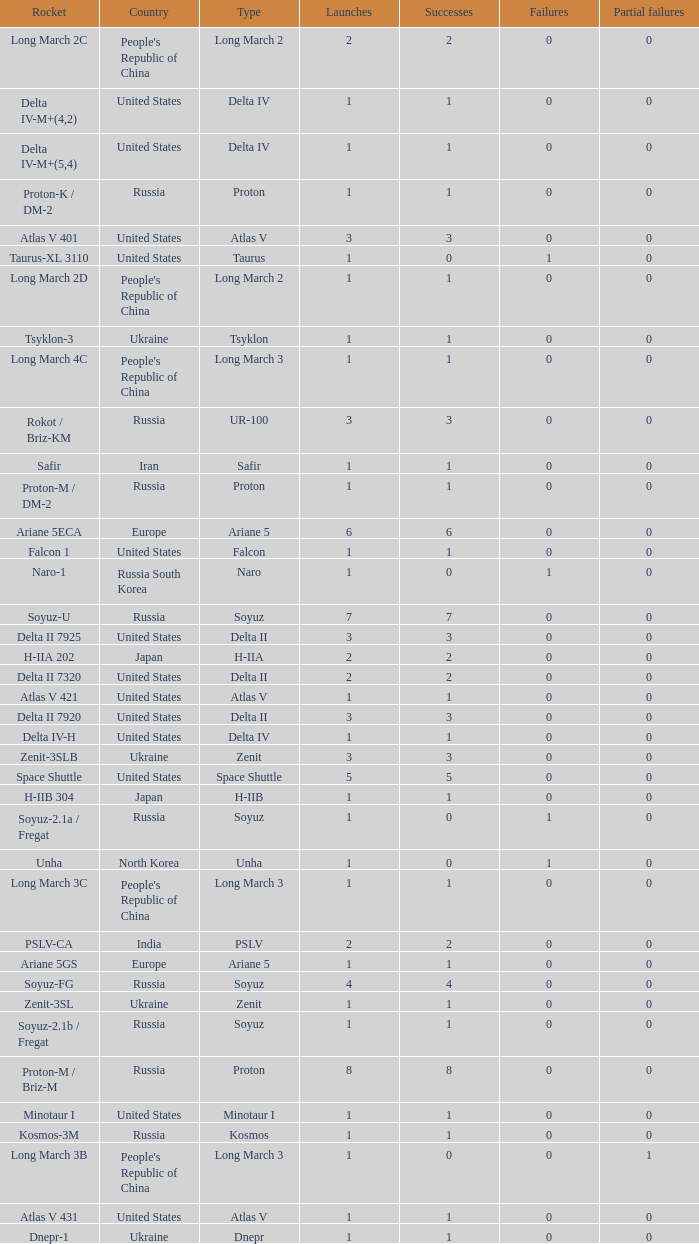What's the total failures among rockets that had more than 3 successes, type ariane 5 and more than 0 partial failures? 0.0. 